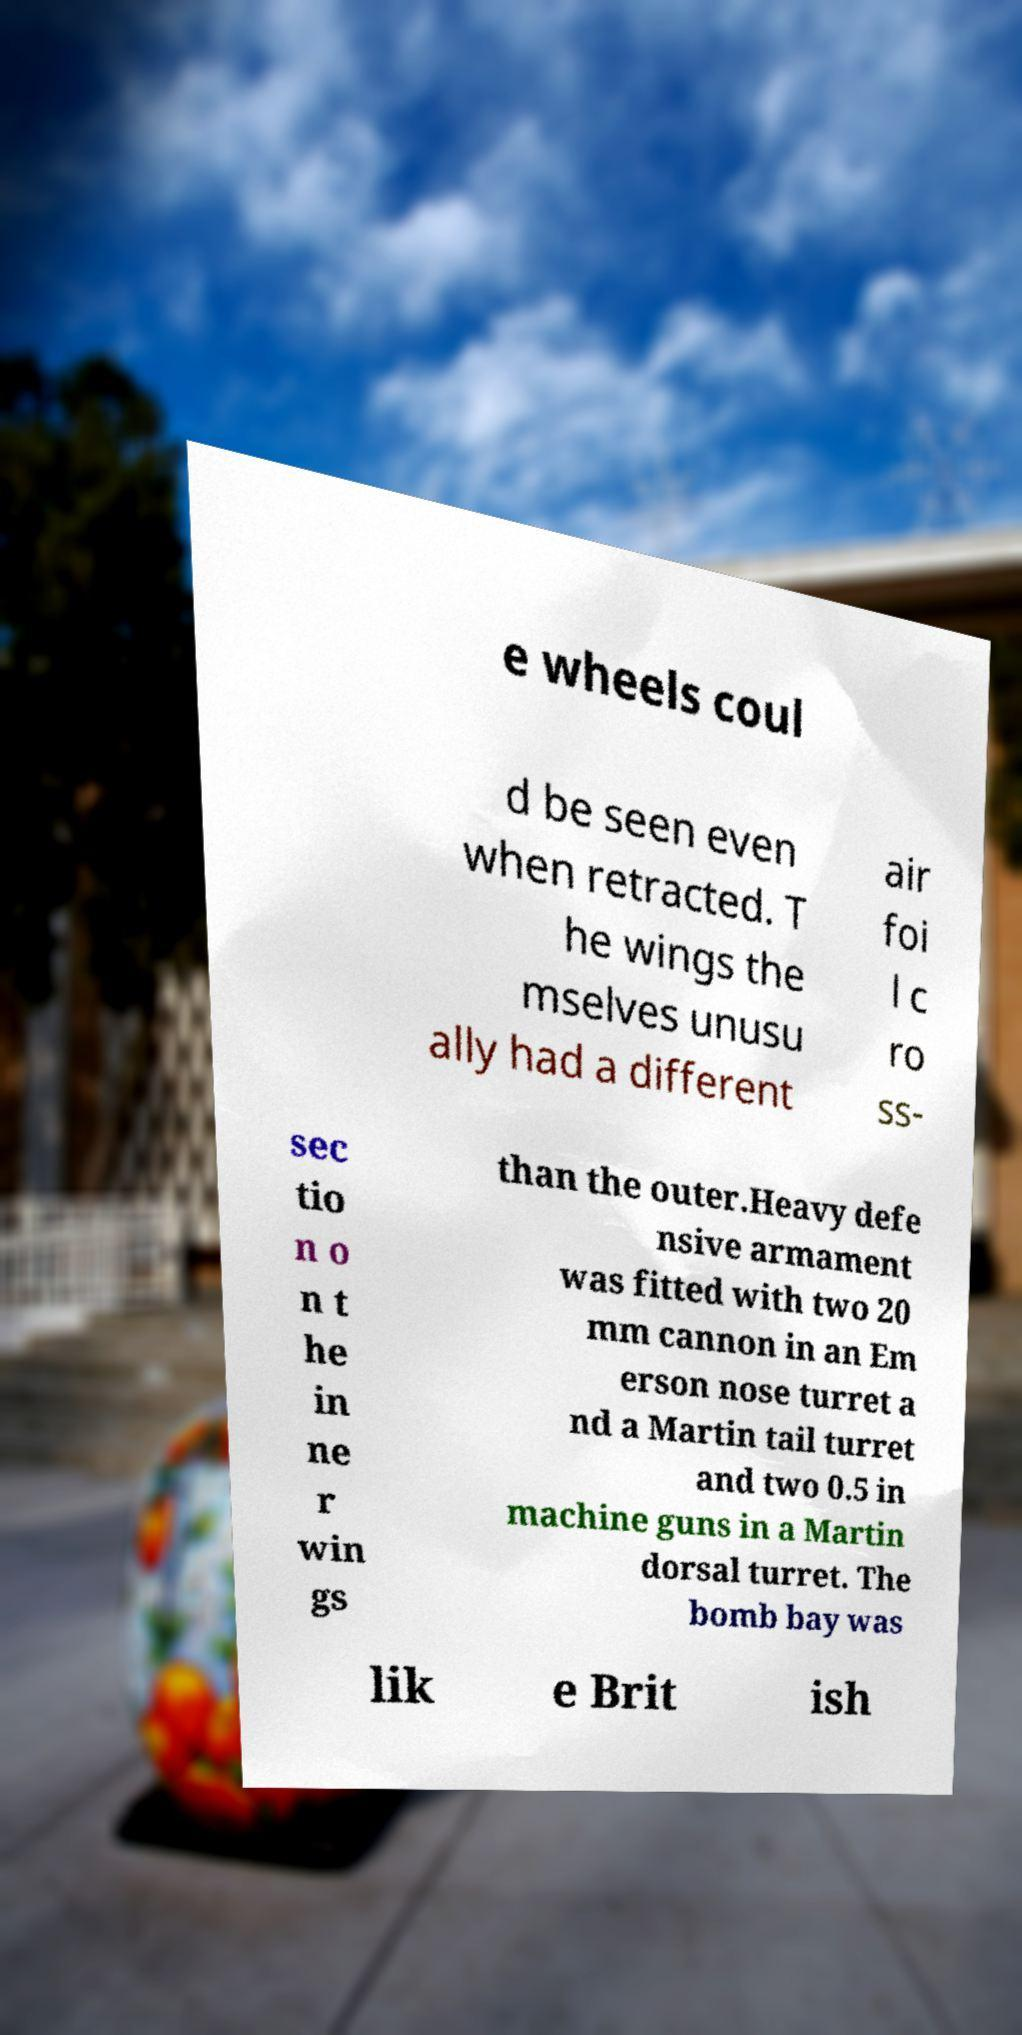Could you extract and type out the text from this image? e wheels coul d be seen even when retracted. T he wings the mselves unusu ally had a different air foi l c ro ss- sec tio n o n t he in ne r win gs than the outer.Heavy defe nsive armament was fitted with two 20 mm cannon in an Em erson nose turret a nd a Martin tail turret and two 0.5 in machine guns in a Martin dorsal turret. The bomb bay was lik e Brit ish 